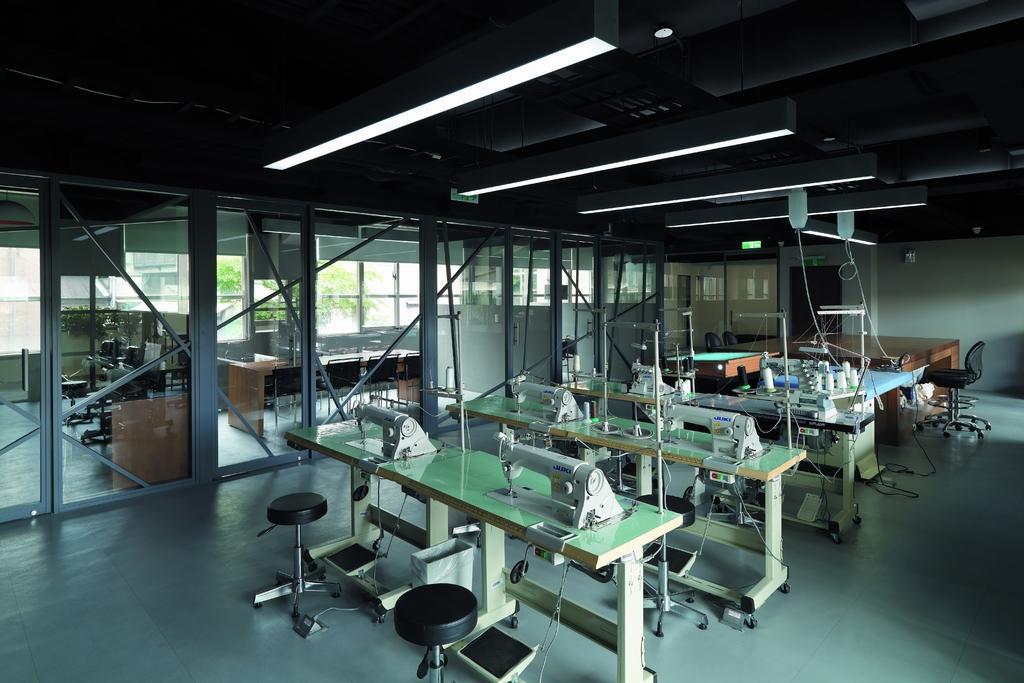Describe this image in one or two sentences. In this image I can see table and machines on it and I can also see number of stools. In the background I can see a chair and a wall. On the ceiling I can see lights. 